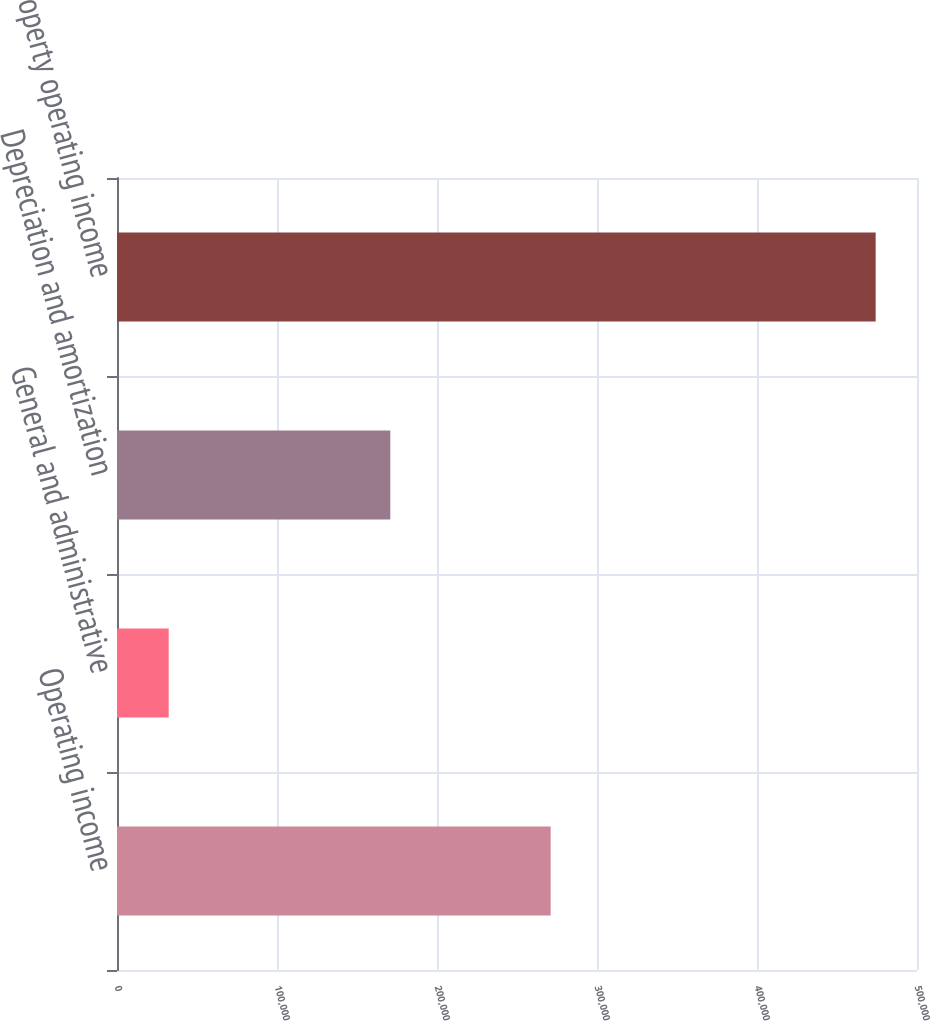Convert chart to OTSL. <chart><loc_0><loc_0><loc_500><loc_500><bar_chart><fcel>Operating income<fcel>General and administrative<fcel>Depreciation and amortization<fcel>Property operating income<nl><fcel>271037<fcel>32316<fcel>170814<fcel>474167<nl></chart> 